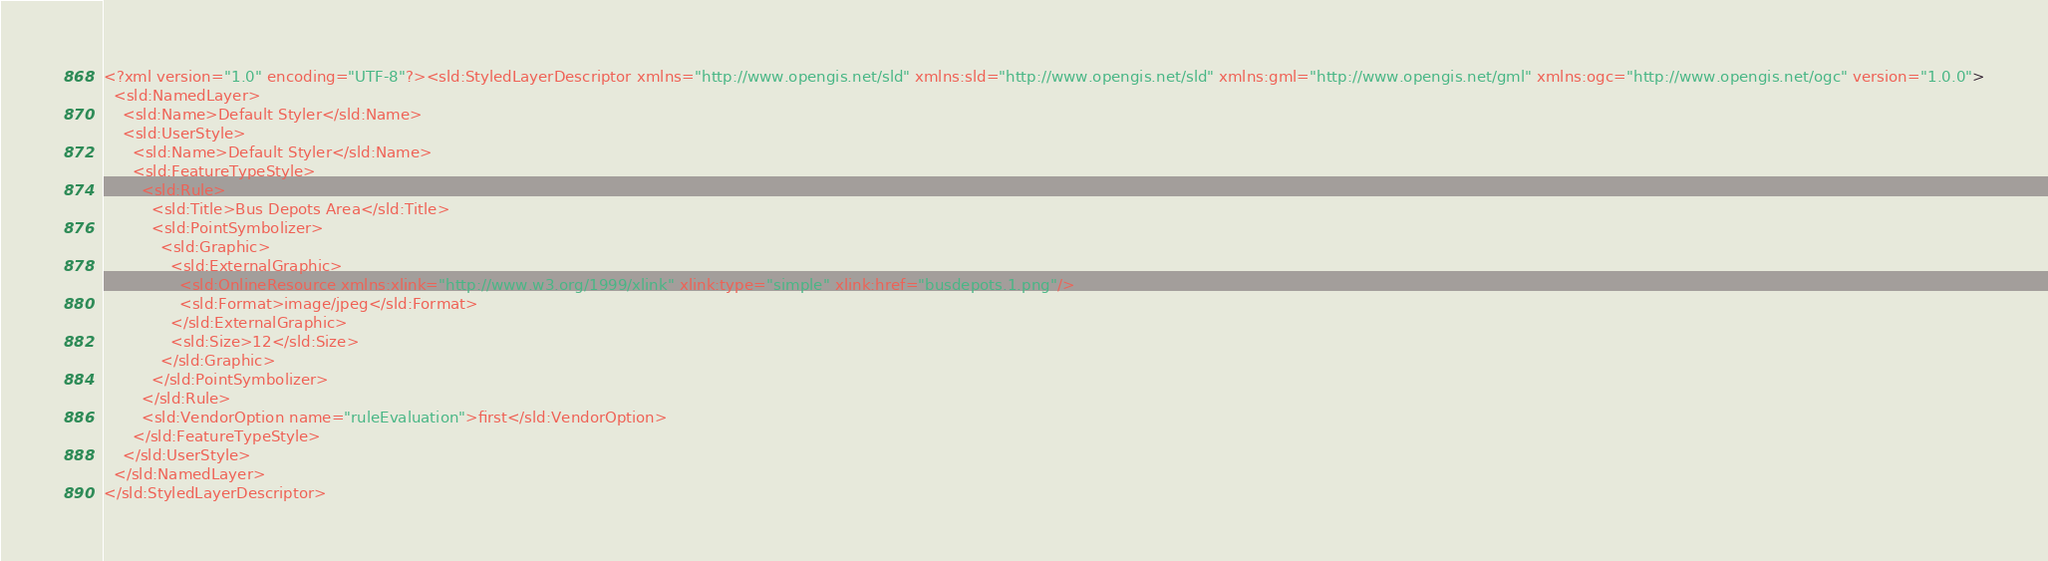Convert code to text. <code><loc_0><loc_0><loc_500><loc_500><_Scheme_><?xml version="1.0" encoding="UTF-8"?><sld:StyledLayerDescriptor xmlns="http://www.opengis.net/sld" xmlns:sld="http://www.opengis.net/sld" xmlns:gml="http://www.opengis.net/gml" xmlns:ogc="http://www.opengis.net/ogc" version="1.0.0">
  <sld:NamedLayer>
    <sld:Name>Default Styler</sld:Name>
    <sld:UserStyle>
      <sld:Name>Default Styler</sld:Name>
      <sld:FeatureTypeStyle>
        <sld:Rule>
          <sld:Title>Bus Depots Area</sld:Title>
          <sld:PointSymbolizer>
            <sld:Graphic>
              <sld:ExternalGraphic>
                <sld:OnlineResource xmlns:xlink="http://www.w3.org/1999/xlink" xlink:type="simple" xlink:href="busdepots.1.png"/>
                <sld:Format>image/jpeg</sld:Format>
              </sld:ExternalGraphic>
              <sld:Size>12</sld:Size>
            </sld:Graphic>
          </sld:PointSymbolizer>
        </sld:Rule>
        <sld:VendorOption name="ruleEvaluation">first</sld:VendorOption>
      </sld:FeatureTypeStyle>
    </sld:UserStyle>
  </sld:NamedLayer>
</sld:StyledLayerDescriptor>

</code> 